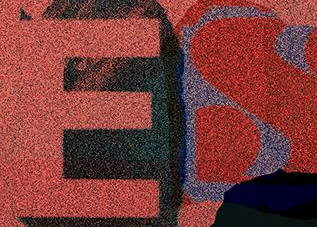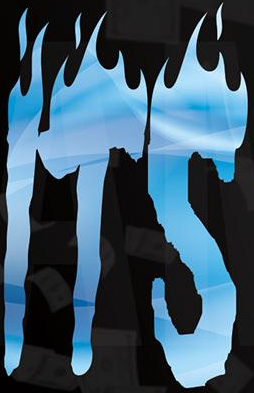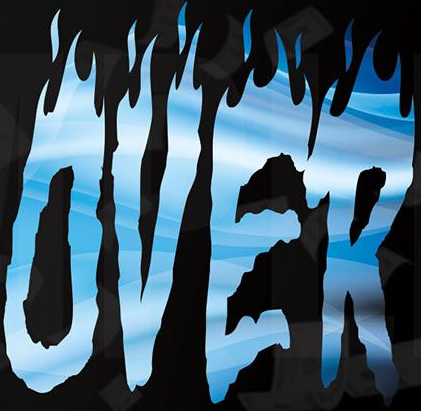Read the text from these images in sequence, separated by a semicolon. ES; ITS; OVER 